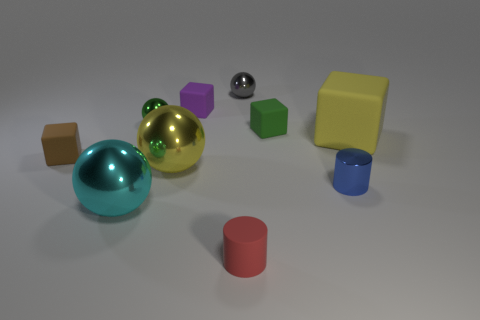There is another thing that is the same color as the big rubber object; what material is it?
Your answer should be very brief. Metal. Does the small blue object have the same material as the green block?
Keep it short and to the point. No. What number of yellow rubber objects are on the right side of the large shiny object that is to the right of the metallic thing in front of the small blue shiny object?
Offer a very short reply. 1. Is there a small purple sphere that has the same material as the yellow ball?
Give a very brief answer. No. There is a shiny sphere that is the same color as the large rubber cube; what is its size?
Make the answer very short. Large. Is the number of big objects less than the number of small objects?
Your answer should be very brief. Yes. Do the rubber object in front of the tiny brown rubber object and the large rubber object have the same color?
Provide a short and direct response. No. There is a cylinder that is on the right side of the green thing on the right side of the small shiny sphere that is behind the small green metallic sphere; what is it made of?
Keep it short and to the point. Metal. Is there a cube that has the same color as the small matte cylinder?
Give a very brief answer. No. Is the number of small green balls that are on the left side of the large cyan metallic sphere less than the number of small brown metal cylinders?
Provide a short and direct response. No. 